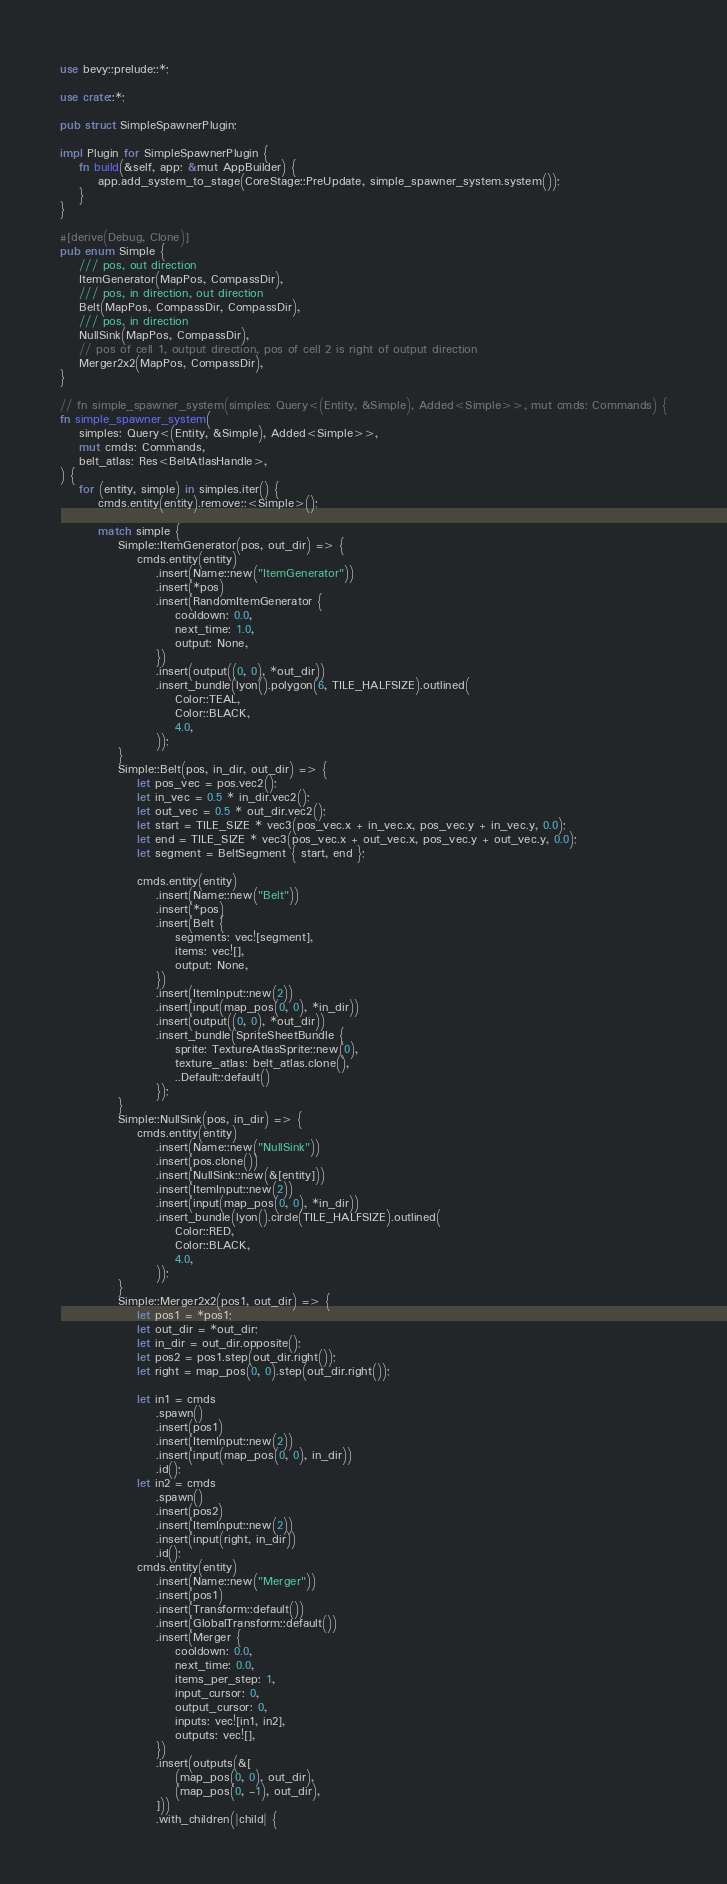Convert code to text. <code><loc_0><loc_0><loc_500><loc_500><_Rust_>use bevy::prelude::*;

use crate::*;

pub struct SimpleSpawnerPlugin;

impl Plugin for SimpleSpawnerPlugin {
    fn build(&self, app: &mut AppBuilder) {
        app.add_system_to_stage(CoreStage::PreUpdate, simple_spawner_system.system());
    }
}

#[derive(Debug, Clone)]
pub enum Simple {
    /// pos, out direction
    ItemGenerator(MapPos, CompassDir),
    /// pos, in direction, out direction
    Belt(MapPos, CompassDir, CompassDir),
    /// pos, in direction
    NullSink(MapPos, CompassDir),
    // pos of cell 1, output direction, pos of cell 2 is right of output direction
    Merger2x2(MapPos, CompassDir),
}

// fn simple_spawner_system(simples: Query<(Entity, &Simple), Added<Simple>>, mut cmds: Commands) {
fn simple_spawner_system(
    simples: Query<(Entity, &Simple), Added<Simple>>,
    mut cmds: Commands,
    belt_atlas: Res<BeltAtlasHandle>,
) {
    for (entity, simple) in simples.iter() {
        cmds.entity(entity).remove::<Simple>();

        match simple {
            Simple::ItemGenerator(pos, out_dir) => {
                cmds.entity(entity)
                    .insert(Name::new("ItemGenerator"))
                    .insert(*pos)
                    .insert(RandomItemGenerator {
                        cooldown: 0.0,
                        next_time: 1.0,
                        output: None,
                    })
                    .insert(output((0, 0), *out_dir))
                    .insert_bundle(lyon().polygon(6, TILE_HALFSIZE).outlined(
                        Color::TEAL,
                        Color::BLACK,
                        4.0,
                    ));
            }
            Simple::Belt(pos, in_dir, out_dir) => {
                let pos_vec = pos.vec2();
                let in_vec = 0.5 * in_dir.vec2();
                let out_vec = 0.5 * out_dir.vec2();
                let start = TILE_SIZE * vec3(pos_vec.x + in_vec.x, pos_vec.y + in_vec.y, 0.0);
                let end = TILE_SIZE * vec3(pos_vec.x + out_vec.x, pos_vec.y + out_vec.y, 0.0);
                let segment = BeltSegment { start, end };

                cmds.entity(entity)
                    .insert(Name::new("Belt"))
                    .insert(*pos)
                    .insert(Belt {
                        segments: vec![segment],
                        items: vec![],
                        output: None,
                    })
                    .insert(ItemInput::new(2))
                    .insert(input(map_pos(0, 0), *in_dir))
                    .insert(output((0, 0), *out_dir))
                    .insert_bundle(SpriteSheetBundle {
                        sprite: TextureAtlasSprite::new(0),
                        texture_atlas: belt_atlas.clone(),
                        ..Default::default()
                    });
            }
            Simple::NullSink(pos, in_dir) => {
                cmds.entity(entity)
                    .insert(Name::new("NullSink"))
                    .insert(pos.clone())
                    .insert(NullSink::new(&[entity]))
                    .insert(ItemInput::new(2))
                    .insert(input(map_pos(0, 0), *in_dir))
                    .insert_bundle(lyon().circle(TILE_HALFSIZE).outlined(
                        Color::RED,
                        Color::BLACK,
                        4.0,
                    ));
            }
            Simple::Merger2x2(pos1, out_dir) => {
                let pos1 = *pos1;
                let out_dir = *out_dir;
                let in_dir = out_dir.opposite();
                let pos2 = pos1.step(out_dir.right());
                let right = map_pos(0, 0).step(out_dir.right());

                let in1 = cmds
                    .spawn()
                    .insert(pos1)
                    .insert(ItemInput::new(2))
                    .insert(input(map_pos(0, 0), in_dir))
                    .id();
                let in2 = cmds
                    .spawn()
                    .insert(pos2)
                    .insert(ItemInput::new(2))
                    .insert(input(right, in_dir))
                    .id();
                cmds.entity(entity)
                    .insert(Name::new("Merger"))
                    .insert(pos1)
                    .insert(Transform::default())
                    .insert(GlobalTransform::default())
                    .insert(Merger {
                        cooldown: 0.0,
                        next_time: 0.0,
                        items_per_step: 1,
                        input_cursor: 0,
                        output_cursor: 0,
                        inputs: vec![in1, in2],
                        outputs: vec![],
                    })
                    .insert(outputs(&[
                        (map_pos(0, 0), out_dir),
                        (map_pos(0, -1), out_dir),
                    ]))
                    .with_children(|child| {</code> 